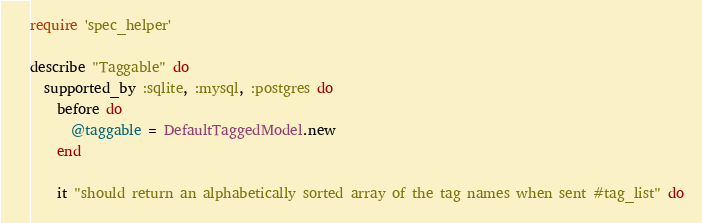<code> <loc_0><loc_0><loc_500><loc_500><_Ruby_>require 'spec_helper'

describe "Taggable" do
  supported_by :sqlite, :mysql, :postgres do
    before do
      @taggable = DefaultTaggedModel.new
    end

    it "should return an alphabetically sorted array of the tag names when sent #tag_list" do</code> 